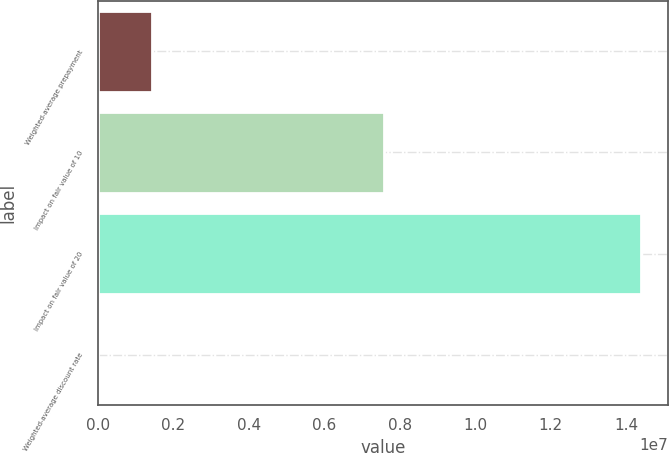Convert chart. <chart><loc_0><loc_0><loc_500><loc_500><bar_chart><fcel>Weighted-average prepayment<fcel>Impact on fair value of 10<fcel>Impact on fair value of 20<fcel>Weighted-average discount rate<nl><fcel>1.43851e+06<fcel>7.574e+06<fcel>1.4385e+07<fcel>9.6<nl></chart> 